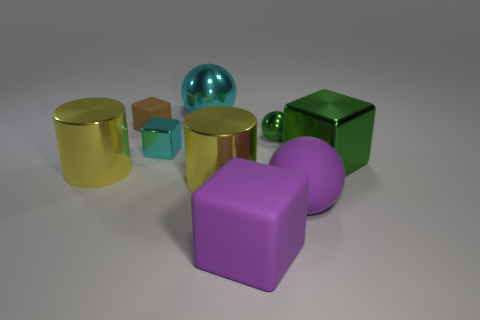How many other things are there of the same color as the matte ball?
Provide a short and direct response. 1. Is there a tiny brown object that has the same shape as the tiny green thing?
Provide a short and direct response. No. Is the material of the green block the same as the yellow object that is to the left of the small brown rubber cube?
Offer a very short reply. Yes. What color is the small sphere?
Your answer should be compact. Green. There is a matte block that is behind the green shiny block in front of the big cyan shiny ball; how many green spheres are behind it?
Your response must be concise. 0. There is a small green sphere; are there any large cyan spheres in front of it?
Provide a short and direct response. No. What number of spheres have the same material as the big green block?
Your answer should be compact. 2. How many things are big objects or green metal cubes?
Keep it short and to the point. 6. Are any purple rubber spheres visible?
Keep it short and to the point. Yes. There is a large sphere left of the purple thing that is left of the rubber sphere to the right of the big purple cube; what is it made of?
Ensure brevity in your answer.  Metal. 